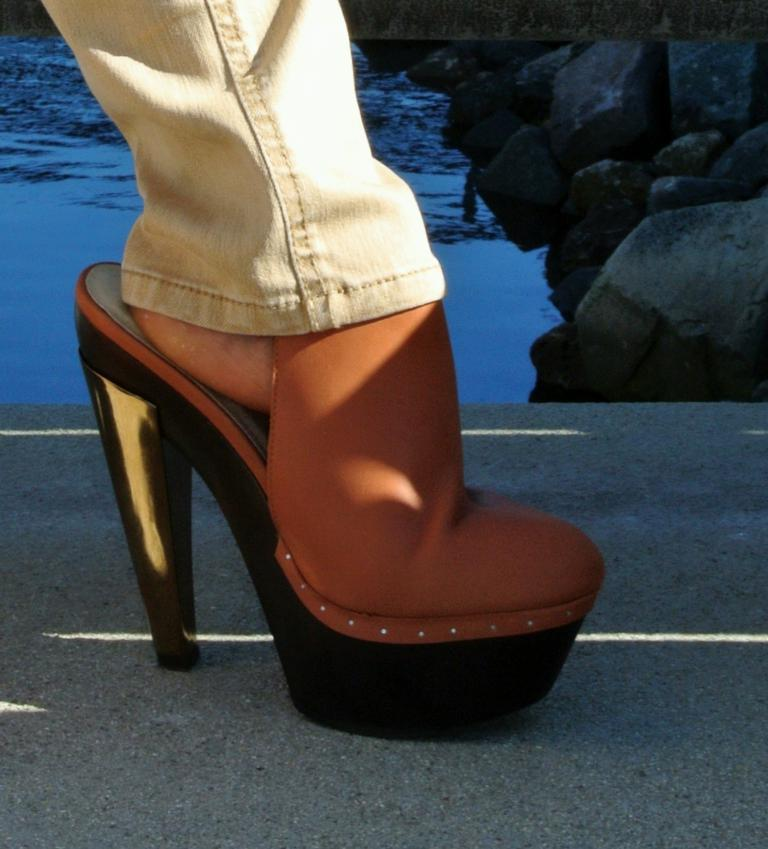What body part is visible in the image? There is a person's leg with a heel in the image. What type of terrain is visible in the image? There are stones visible in the image. What natural element is present in the image? There is water visible in the image. What type of pickle is being used as a prop in the image? There is no pickle present in the image. What type of car can be seen driving through the water in the image? There is no car present in the image. 